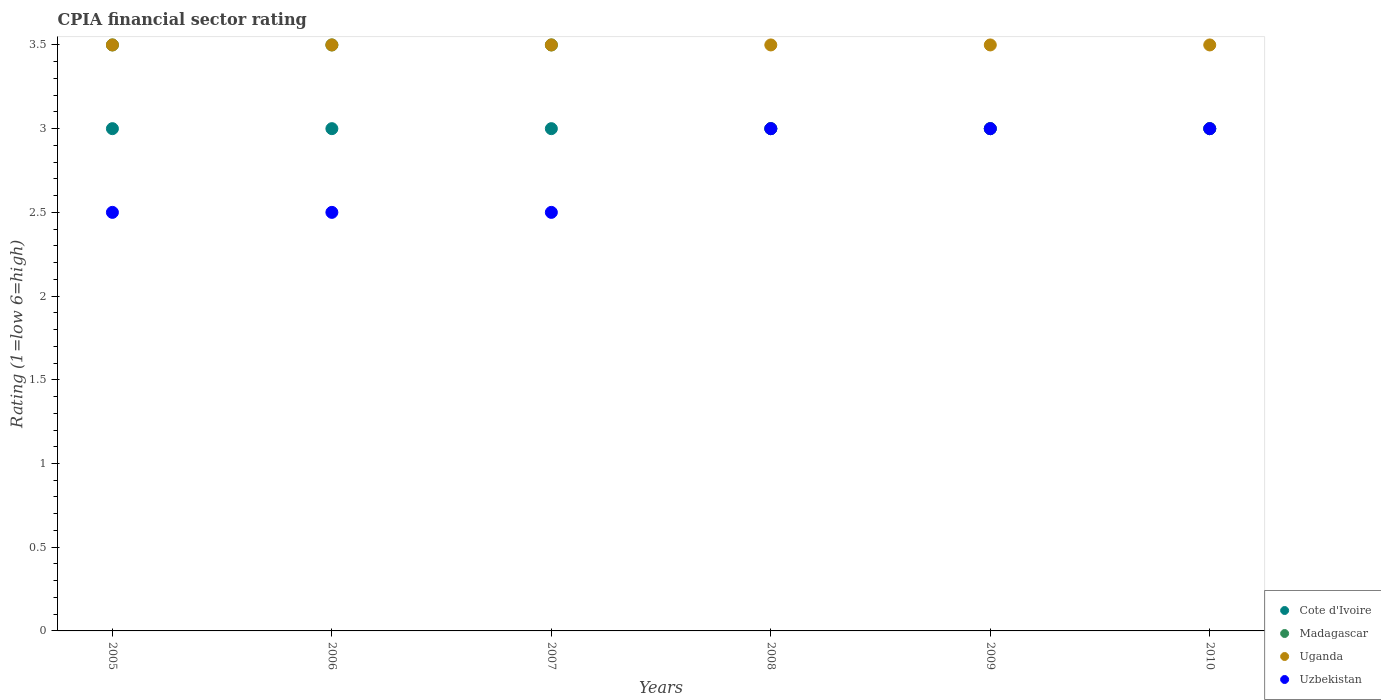How many different coloured dotlines are there?
Offer a very short reply. 4. Is the number of dotlines equal to the number of legend labels?
Ensure brevity in your answer.  Yes. Across all years, what is the maximum CPIA rating in Madagascar?
Make the answer very short. 3.5. In which year was the CPIA rating in Cote d'Ivoire maximum?
Keep it short and to the point. 2005. What is the total CPIA rating in Uzbekistan in the graph?
Your answer should be very brief. 16.5. What is the difference between the CPIA rating in Uzbekistan in 2005 and the CPIA rating in Cote d'Ivoire in 2009?
Your answer should be compact. -0.5. What is the average CPIA rating in Cote d'Ivoire per year?
Your answer should be compact. 3. In the year 2006, what is the difference between the CPIA rating in Uganda and CPIA rating in Madagascar?
Make the answer very short. 0. In how many years, is the CPIA rating in Uganda greater than 2.1?
Your answer should be compact. 6. What is the ratio of the CPIA rating in Cote d'Ivoire in 2005 to that in 2010?
Give a very brief answer. 1. Is the difference between the CPIA rating in Uganda in 2005 and 2009 greater than the difference between the CPIA rating in Madagascar in 2005 and 2009?
Offer a terse response. No. In how many years, is the CPIA rating in Cote d'Ivoire greater than the average CPIA rating in Cote d'Ivoire taken over all years?
Give a very brief answer. 0. Does the CPIA rating in Madagascar monotonically increase over the years?
Your answer should be compact. No. Is the CPIA rating in Uzbekistan strictly less than the CPIA rating in Cote d'Ivoire over the years?
Ensure brevity in your answer.  No. How many dotlines are there?
Provide a succinct answer. 4. How many years are there in the graph?
Give a very brief answer. 6. What is the difference between two consecutive major ticks on the Y-axis?
Your answer should be very brief. 0.5. Does the graph contain any zero values?
Your response must be concise. No. How are the legend labels stacked?
Your answer should be very brief. Vertical. What is the title of the graph?
Your answer should be compact. CPIA financial sector rating. What is the label or title of the X-axis?
Provide a short and direct response. Years. What is the label or title of the Y-axis?
Your response must be concise. Rating (1=low 6=high). What is the Rating (1=low 6=high) of Madagascar in 2005?
Your response must be concise. 3.5. What is the Rating (1=low 6=high) of Uganda in 2005?
Offer a very short reply. 3.5. What is the Rating (1=low 6=high) of Cote d'Ivoire in 2006?
Provide a short and direct response. 3. What is the Rating (1=low 6=high) in Madagascar in 2006?
Your response must be concise. 3.5. What is the Rating (1=low 6=high) in Uzbekistan in 2006?
Provide a succinct answer. 2.5. What is the Rating (1=low 6=high) of Cote d'Ivoire in 2007?
Your response must be concise. 3. What is the Rating (1=low 6=high) of Madagascar in 2007?
Provide a succinct answer. 3.5. What is the Rating (1=low 6=high) in Uganda in 2007?
Keep it short and to the point. 3.5. What is the Rating (1=low 6=high) of Uzbekistan in 2007?
Offer a very short reply. 2.5. What is the Rating (1=low 6=high) of Cote d'Ivoire in 2008?
Keep it short and to the point. 3. What is the Rating (1=low 6=high) in Uzbekistan in 2008?
Keep it short and to the point. 3. What is the Rating (1=low 6=high) of Cote d'Ivoire in 2009?
Provide a succinct answer. 3. What is the Rating (1=low 6=high) in Madagascar in 2009?
Offer a terse response. 3. What is the Rating (1=low 6=high) in Uzbekistan in 2009?
Keep it short and to the point. 3. What is the Rating (1=low 6=high) of Uganda in 2010?
Offer a very short reply. 3.5. What is the Rating (1=low 6=high) of Uzbekistan in 2010?
Your answer should be very brief. 3. Across all years, what is the maximum Rating (1=low 6=high) of Uganda?
Ensure brevity in your answer.  3.5. Across all years, what is the minimum Rating (1=low 6=high) of Cote d'Ivoire?
Offer a very short reply. 3. Across all years, what is the minimum Rating (1=low 6=high) of Madagascar?
Provide a succinct answer. 3. Across all years, what is the minimum Rating (1=low 6=high) of Uganda?
Offer a very short reply. 3.5. Across all years, what is the minimum Rating (1=low 6=high) in Uzbekistan?
Ensure brevity in your answer.  2.5. What is the total Rating (1=low 6=high) of Uzbekistan in the graph?
Offer a very short reply. 16.5. What is the difference between the Rating (1=low 6=high) in Uganda in 2005 and that in 2006?
Make the answer very short. 0. What is the difference between the Rating (1=low 6=high) of Madagascar in 2005 and that in 2007?
Your response must be concise. 0. What is the difference between the Rating (1=low 6=high) in Uganda in 2005 and that in 2007?
Your response must be concise. 0. What is the difference between the Rating (1=low 6=high) of Uzbekistan in 2005 and that in 2007?
Offer a very short reply. 0. What is the difference between the Rating (1=low 6=high) in Cote d'Ivoire in 2005 and that in 2008?
Offer a terse response. 0. What is the difference between the Rating (1=low 6=high) in Uganda in 2005 and that in 2008?
Provide a succinct answer. 0. What is the difference between the Rating (1=low 6=high) in Madagascar in 2005 and that in 2009?
Ensure brevity in your answer.  0.5. What is the difference between the Rating (1=low 6=high) in Uganda in 2005 and that in 2009?
Offer a terse response. 0. What is the difference between the Rating (1=low 6=high) of Madagascar in 2005 and that in 2010?
Your response must be concise. 0.5. What is the difference between the Rating (1=low 6=high) in Uganda in 2005 and that in 2010?
Provide a succinct answer. 0. What is the difference between the Rating (1=low 6=high) in Uzbekistan in 2005 and that in 2010?
Your response must be concise. -0.5. What is the difference between the Rating (1=low 6=high) in Uzbekistan in 2006 and that in 2007?
Your response must be concise. 0. What is the difference between the Rating (1=low 6=high) of Cote d'Ivoire in 2006 and that in 2008?
Give a very brief answer. 0. What is the difference between the Rating (1=low 6=high) of Uganda in 2006 and that in 2008?
Offer a very short reply. 0. What is the difference between the Rating (1=low 6=high) in Uganda in 2006 and that in 2009?
Provide a succinct answer. 0. What is the difference between the Rating (1=low 6=high) in Cote d'Ivoire in 2006 and that in 2010?
Your answer should be very brief. 0. What is the difference between the Rating (1=low 6=high) of Uganda in 2006 and that in 2010?
Keep it short and to the point. 0. What is the difference between the Rating (1=low 6=high) of Uzbekistan in 2006 and that in 2010?
Offer a very short reply. -0.5. What is the difference between the Rating (1=low 6=high) in Uganda in 2007 and that in 2009?
Your answer should be very brief. 0. What is the difference between the Rating (1=low 6=high) in Cote d'Ivoire in 2007 and that in 2010?
Ensure brevity in your answer.  0. What is the difference between the Rating (1=low 6=high) in Madagascar in 2007 and that in 2010?
Give a very brief answer. 0.5. What is the difference between the Rating (1=low 6=high) of Uzbekistan in 2007 and that in 2010?
Offer a terse response. -0.5. What is the difference between the Rating (1=low 6=high) in Cote d'Ivoire in 2008 and that in 2009?
Provide a succinct answer. 0. What is the difference between the Rating (1=low 6=high) of Madagascar in 2008 and that in 2010?
Provide a succinct answer. 0. What is the difference between the Rating (1=low 6=high) of Uganda in 2008 and that in 2010?
Your response must be concise. 0. What is the difference between the Rating (1=low 6=high) in Cote d'Ivoire in 2005 and the Rating (1=low 6=high) in Madagascar in 2006?
Ensure brevity in your answer.  -0.5. What is the difference between the Rating (1=low 6=high) of Cote d'Ivoire in 2005 and the Rating (1=low 6=high) of Uganda in 2006?
Keep it short and to the point. -0.5. What is the difference between the Rating (1=low 6=high) of Madagascar in 2005 and the Rating (1=low 6=high) of Uganda in 2006?
Provide a short and direct response. 0. What is the difference between the Rating (1=low 6=high) in Cote d'Ivoire in 2005 and the Rating (1=low 6=high) in Madagascar in 2007?
Keep it short and to the point. -0.5. What is the difference between the Rating (1=low 6=high) in Cote d'Ivoire in 2005 and the Rating (1=low 6=high) in Uganda in 2007?
Your answer should be very brief. -0.5. What is the difference between the Rating (1=low 6=high) of Cote d'Ivoire in 2005 and the Rating (1=low 6=high) of Uzbekistan in 2007?
Ensure brevity in your answer.  0.5. What is the difference between the Rating (1=low 6=high) in Madagascar in 2005 and the Rating (1=low 6=high) in Uganda in 2007?
Ensure brevity in your answer.  0. What is the difference between the Rating (1=low 6=high) in Madagascar in 2005 and the Rating (1=low 6=high) in Uzbekistan in 2007?
Make the answer very short. 1. What is the difference between the Rating (1=low 6=high) of Madagascar in 2005 and the Rating (1=low 6=high) of Uganda in 2008?
Offer a terse response. 0. What is the difference between the Rating (1=low 6=high) of Uganda in 2005 and the Rating (1=low 6=high) of Uzbekistan in 2008?
Give a very brief answer. 0.5. What is the difference between the Rating (1=low 6=high) of Madagascar in 2005 and the Rating (1=low 6=high) of Uganda in 2009?
Ensure brevity in your answer.  0. What is the difference between the Rating (1=low 6=high) of Madagascar in 2005 and the Rating (1=low 6=high) of Uzbekistan in 2009?
Ensure brevity in your answer.  0.5. What is the difference between the Rating (1=low 6=high) of Uganda in 2005 and the Rating (1=low 6=high) of Uzbekistan in 2009?
Your answer should be very brief. 0.5. What is the difference between the Rating (1=low 6=high) of Cote d'Ivoire in 2005 and the Rating (1=low 6=high) of Madagascar in 2010?
Make the answer very short. 0. What is the difference between the Rating (1=low 6=high) of Cote d'Ivoire in 2005 and the Rating (1=low 6=high) of Uganda in 2010?
Keep it short and to the point. -0.5. What is the difference between the Rating (1=low 6=high) in Madagascar in 2006 and the Rating (1=low 6=high) in Uzbekistan in 2007?
Make the answer very short. 1. What is the difference between the Rating (1=low 6=high) of Uganda in 2006 and the Rating (1=low 6=high) of Uzbekistan in 2007?
Give a very brief answer. 1. What is the difference between the Rating (1=low 6=high) in Cote d'Ivoire in 2006 and the Rating (1=low 6=high) in Madagascar in 2008?
Keep it short and to the point. 0. What is the difference between the Rating (1=low 6=high) of Cote d'Ivoire in 2006 and the Rating (1=low 6=high) of Uganda in 2008?
Keep it short and to the point. -0.5. What is the difference between the Rating (1=low 6=high) of Cote d'Ivoire in 2006 and the Rating (1=low 6=high) of Uzbekistan in 2008?
Your answer should be very brief. 0. What is the difference between the Rating (1=low 6=high) in Uganda in 2006 and the Rating (1=low 6=high) in Uzbekistan in 2008?
Keep it short and to the point. 0.5. What is the difference between the Rating (1=low 6=high) in Cote d'Ivoire in 2006 and the Rating (1=low 6=high) in Uganda in 2009?
Your answer should be very brief. -0.5. What is the difference between the Rating (1=low 6=high) in Madagascar in 2006 and the Rating (1=low 6=high) in Uganda in 2009?
Your answer should be compact. 0. What is the difference between the Rating (1=low 6=high) of Madagascar in 2006 and the Rating (1=low 6=high) of Uzbekistan in 2009?
Provide a succinct answer. 0.5. What is the difference between the Rating (1=low 6=high) of Uganda in 2006 and the Rating (1=low 6=high) of Uzbekistan in 2009?
Ensure brevity in your answer.  0.5. What is the difference between the Rating (1=low 6=high) of Cote d'Ivoire in 2006 and the Rating (1=low 6=high) of Madagascar in 2010?
Ensure brevity in your answer.  0. What is the difference between the Rating (1=low 6=high) of Cote d'Ivoire in 2006 and the Rating (1=low 6=high) of Uganda in 2010?
Your answer should be compact. -0.5. What is the difference between the Rating (1=low 6=high) in Cote d'Ivoire in 2006 and the Rating (1=low 6=high) in Uzbekistan in 2010?
Offer a very short reply. 0. What is the difference between the Rating (1=low 6=high) of Madagascar in 2006 and the Rating (1=low 6=high) of Uzbekistan in 2010?
Provide a short and direct response. 0.5. What is the difference between the Rating (1=low 6=high) of Uganda in 2006 and the Rating (1=low 6=high) of Uzbekistan in 2010?
Offer a very short reply. 0.5. What is the difference between the Rating (1=low 6=high) in Cote d'Ivoire in 2007 and the Rating (1=low 6=high) in Uzbekistan in 2008?
Keep it short and to the point. 0. What is the difference between the Rating (1=low 6=high) of Uganda in 2007 and the Rating (1=low 6=high) of Uzbekistan in 2008?
Your answer should be very brief. 0.5. What is the difference between the Rating (1=low 6=high) in Cote d'Ivoire in 2007 and the Rating (1=low 6=high) in Uzbekistan in 2009?
Offer a terse response. 0. What is the difference between the Rating (1=low 6=high) in Uganda in 2007 and the Rating (1=low 6=high) in Uzbekistan in 2009?
Make the answer very short. 0.5. What is the difference between the Rating (1=low 6=high) of Cote d'Ivoire in 2007 and the Rating (1=low 6=high) of Madagascar in 2010?
Offer a very short reply. 0. What is the difference between the Rating (1=low 6=high) in Cote d'Ivoire in 2007 and the Rating (1=low 6=high) in Uganda in 2010?
Your response must be concise. -0.5. What is the difference between the Rating (1=low 6=high) in Cote d'Ivoire in 2007 and the Rating (1=low 6=high) in Uzbekistan in 2010?
Provide a short and direct response. 0. What is the difference between the Rating (1=low 6=high) in Cote d'Ivoire in 2008 and the Rating (1=low 6=high) in Uzbekistan in 2009?
Ensure brevity in your answer.  0. What is the difference between the Rating (1=low 6=high) in Madagascar in 2008 and the Rating (1=low 6=high) in Uganda in 2009?
Offer a terse response. -0.5. What is the difference between the Rating (1=low 6=high) in Cote d'Ivoire in 2008 and the Rating (1=low 6=high) in Madagascar in 2010?
Provide a succinct answer. 0. What is the difference between the Rating (1=low 6=high) in Madagascar in 2008 and the Rating (1=low 6=high) in Uzbekistan in 2010?
Give a very brief answer. 0. What is the difference between the Rating (1=low 6=high) in Cote d'Ivoire in 2009 and the Rating (1=low 6=high) in Uganda in 2010?
Make the answer very short. -0.5. What is the difference between the Rating (1=low 6=high) of Cote d'Ivoire in 2009 and the Rating (1=low 6=high) of Uzbekistan in 2010?
Provide a succinct answer. 0. What is the difference between the Rating (1=low 6=high) of Madagascar in 2009 and the Rating (1=low 6=high) of Uganda in 2010?
Your response must be concise. -0.5. What is the difference between the Rating (1=low 6=high) of Madagascar in 2009 and the Rating (1=low 6=high) of Uzbekistan in 2010?
Keep it short and to the point. 0. What is the difference between the Rating (1=low 6=high) in Uganda in 2009 and the Rating (1=low 6=high) in Uzbekistan in 2010?
Offer a very short reply. 0.5. What is the average Rating (1=low 6=high) in Cote d'Ivoire per year?
Offer a very short reply. 3. What is the average Rating (1=low 6=high) of Madagascar per year?
Ensure brevity in your answer.  3.25. What is the average Rating (1=low 6=high) of Uzbekistan per year?
Give a very brief answer. 2.75. In the year 2005, what is the difference between the Rating (1=low 6=high) of Cote d'Ivoire and Rating (1=low 6=high) of Madagascar?
Your response must be concise. -0.5. In the year 2005, what is the difference between the Rating (1=low 6=high) in Cote d'Ivoire and Rating (1=low 6=high) in Uganda?
Ensure brevity in your answer.  -0.5. In the year 2005, what is the difference between the Rating (1=low 6=high) of Madagascar and Rating (1=low 6=high) of Uzbekistan?
Offer a terse response. 1. In the year 2005, what is the difference between the Rating (1=low 6=high) in Uganda and Rating (1=low 6=high) in Uzbekistan?
Make the answer very short. 1. In the year 2006, what is the difference between the Rating (1=low 6=high) in Cote d'Ivoire and Rating (1=low 6=high) in Uganda?
Ensure brevity in your answer.  -0.5. In the year 2006, what is the difference between the Rating (1=low 6=high) in Madagascar and Rating (1=low 6=high) in Uzbekistan?
Provide a succinct answer. 1. In the year 2007, what is the difference between the Rating (1=low 6=high) in Cote d'Ivoire and Rating (1=low 6=high) in Uganda?
Provide a short and direct response. -0.5. In the year 2007, what is the difference between the Rating (1=low 6=high) of Cote d'Ivoire and Rating (1=low 6=high) of Uzbekistan?
Give a very brief answer. 0.5. In the year 2007, what is the difference between the Rating (1=low 6=high) of Madagascar and Rating (1=low 6=high) of Uganda?
Provide a succinct answer. 0. In the year 2007, what is the difference between the Rating (1=low 6=high) in Uganda and Rating (1=low 6=high) in Uzbekistan?
Offer a terse response. 1. In the year 2008, what is the difference between the Rating (1=low 6=high) of Cote d'Ivoire and Rating (1=low 6=high) of Madagascar?
Ensure brevity in your answer.  0. In the year 2008, what is the difference between the Rating (1=low 6=high) in Cote d'Ivoire and Rating (1=low 6=high) in Uganda?
Offer a terse response. -0.5. In the year 2008, what is the difference between the Rating (1=low 6=high) of Uganda and Rating (1=low 6=high) of Uzbekistan?
Offer a very short reply. 0.5. In the year 2009, what is the difference between the Rating (1=low 6=high) in Cote d'Ivoire and Rating (1=low 6=high) in Uzbekistan?
Offer a terse response. 0. In the year 2009, what is the difference between the Rating (1=low 6=high) in Madagascar and Rating (1=low 6=high) in Uzbekistan?
Your answer should be very brief. 0. In the year 2009, what is the difference between the Rating (1=low 6=high) in Uganda and Rating (1=low 6=high) in Uzbekistan?
Offer a very short reply. 0.5. In the year 2010, what is the difference between the Rating (1=low 6=high) in Cote d'Ivoire and Rating (1=low 6=high) in Uzbekistan?
Give a very brief answer. 0. In the year 2010, what is the difference between the Rating (1=low 6=high) in Madagascar and Rating (1=low 6=high) in Uzbekistan?
Offer a very short reply. 0. What is the ratio of the Rating (1=low 6=high) of Uganda in 2005 to that in 2006?
Provide a short and direct response. 1. What is the ratio of the Rating (1=low 6=high) of Cote d'Ivoire in 2005 to that in 2007?
Your answer should be compact. 1. What is the ratio of the Rating (1=low 6=high) in Madagascar in 2005 to that in 2007?
Make the answer very short. 1. What is the ratio of the Rating (1=low 6=high) in Cote d'Ivoire in 2005 to that in 2008?
Keep it short and to the point. 1. What is the ratio of the Rating (1=low 6=high) in Madagascar in 2005 to that in 2008?
Your answer should be very brief. 1.17. What is the ratio of the Rating (1=low 6=high) in Cote d'Ivoire in 2005 to that in 2009?
Provide a succinct answer. 1. What is the ratio of the Rating (1=low 6=high) in Madagascar in 2005 to that in 2009?
Offer a terse response. 1.17. What is the ratio of the Rating (1=low 6=high) of Uzbekistan in 2005 to that in 2009?
Keep it short and to the point. 0.83. What is the ratio of the Rating (1=low 6=high) in Cote d'Ivoire in 2005 to that in 2010?
Provide a short and direct response. 1. What is the ratio of the Rating (1=low 6=high) of Madagascar in 2005 to that in 2010?
Ensure brevity in your answer.  1.17. What is the ratio of the Rating (1=low 6=high) in Uganda in 2005 to that in 2010?
Make the answer very short. 1. What is the ratio of the Rating (1=low 6=high) in Uzbekistan in 2005 to that in 2010?
Give a very brief answer. 0.83. What is the ratio of the Rating (1=low 6=high) in Cote d'Ivoire in 2006 to that in 2007?
Your response must be concise. 1. What is the ratio of the Rating (1=low 6=high) in Madagascar in 2006 to that in 2007?
Your answer should be very brief. 1. What is the ratio of the Rating (1=low 6=high) in Uzbekistan in 2006 to that in 2007?
Your answer should be compact. 1. What is the ratio of the Rating (1=low 6=high) of Cote d'Ivoire in 2006 to that in 2008?
Offer a very short reply. 1. What is the ratio of the Rating (1=low 6=high) in Uzbekistan in 2006 to that in 2008?
Provide a short and direct response. 0.83. What is the ratio of the Rating (1=low 6=high) of Cote d'Ivoire in 2006 to that in 2009?
Your answer should be very brief. 1. What is the ratio of the Rating (1=low 6=high) of Uganda in 2006 to that in 2009?
Give a very brief answer. 1. What is the ratio of the Rating (1=low 6=high) in Uzbekistan in 2006 to that in 2010?
Keep it short and to the point. 0.83. What is the ratio of the Rating (1=low 6=high) in Cote d'Ivoire in 2007 to that in 2008?
Offer a very short reply. 1. What is the ratio of the Rating (1=low 6=high) of Madagascar in 2007 to that in 2008?
Offer a terse response. 1.17. What is the ratio of the Rating (1=low 6=high) in Uzbekistan in 2007 to that in 2008?
Provide a short and direct response. 0.83. What is the ratio of the Rating (1=low 6=high) of Madagascar in 2007 to that in 2010?
Offer a very short reply. 1.17. What is the ratio of the Rating (1=low 6=high) in Uganda in 2007 to that in 2010?
Your response must be concise. 1. What is the ratio of the Rating (1=low 6=high) in Uzbekistan in 2007 to that in 2010?
Offer a very short reply. 0.83. What is the ratio of the Rating (1=low 6=high) of Madagascar in 2008 to that in 2009?
Provide a short and direct response. 1. What is the ratio of the Rating (1=low 6=high) of Uzbekistan in 2008 to that in 2009?
Offer a terse response. 1. What is the ratio of the Rating (1=low 6=high) of Cote d'Ivoire in 2008 to that in 2010?
Provide a short and direct response. 1. What is the ratio of the Rating (1=low 6=high) in Madagascar in 2008 to that in 2010?
Offer a very short reply. 1. What is the ratio of the Rating (1=low 6=high) of Uzbekistan in 2008 to that in 2010?
Keep it short and to the point. 1. What is the ratio of the Rating (1=low 6=high) in Cote d'Ivoire in 2009 to that in 2010?
Make the answer very short. 1. What is the ratio of the Rating (1=low 6=high) in Madagascar in 2009 to that in 2010?
Your answer should be compact. 1. What is the ratio of the Rating (1=low 6=high) of Uganda in 2009 to that in 2010?
Provide a short and direct response. 1. What is the difference between the highest and the second highest Rating (1=low 6=high) of Cote d'Ivoire?
Make the answer very short. 0. What is the difference between the highest and the second highest Rating (1=low 6=high) in Uganda?
Your answer should be very brief. 0. What is the difference between the highest and the lowest Rating (1=low 6=high) of Cote d'Ivoire?
Keep it short and to the point. 0. 